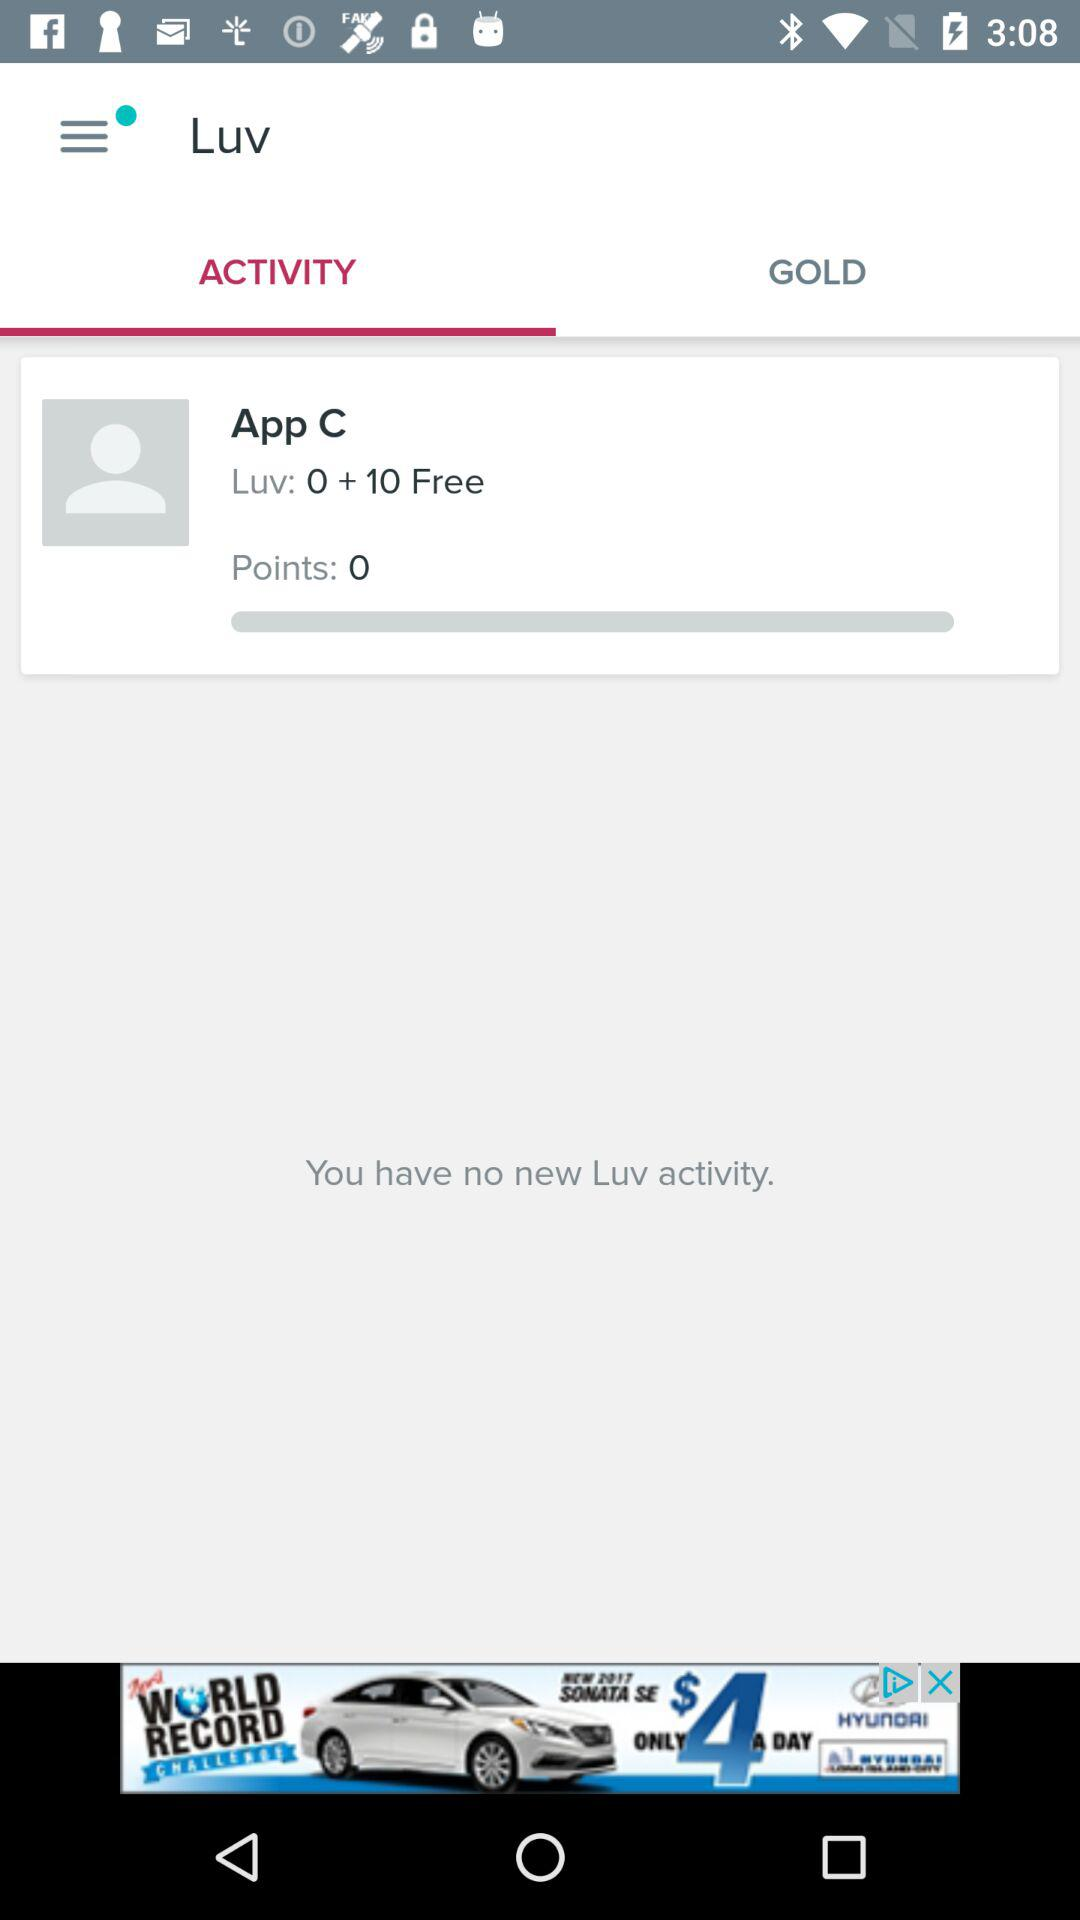How many points does App C have? The App C has 0 points. 